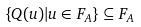Convert formula to latex. <formula><loc_0><loc_0><loc_500><loc_500>\{ Q ( u ) | u \in F _ { A } \} \subseteq F _ { A }</formula> 